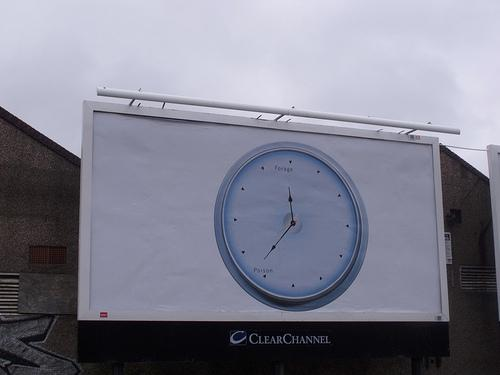How many significant objects can you identify in the image and what are some of the most important ones? There are numerous objects in the image, some important ones include the clear channel billboard, clock, graffiti, and air vent. What is unique about the clock's hands in the image? The clock's black hands are showing the time as eleven forty and are unusually large when compared to the face of the clock. List three elements featured on the billboard and provide their color. The billboard features a big clock with a silver frame, a white face, and blue border on the edge. Examine and describe the appearance of the clock on the billboard. The clock on the billboard has a silver frame, a white face, black dots marking hours, black hands, and a blue border on the edge. Mention an element of color or design that stands out in the image. A notable design element in the image is the red label and red sticker, both visually contrasting against the predominantly white and gray color scheme. Analyze and describe the placement and purpose of the Clear Channel logo in the image. The Clear Channel logo is positioned in white lettering on a black background below the billboard, indicating the ownership of the billboard. What is the state of the sky above the advertisement? The sky is gray and gloomy, indicating an overcast or stormy atmosphere. What does the graffiti under the advertisement look like, based on the image? The graffiti under the advertisement is mostly white with a black "S" painted on the wall and black letters on a white background. Provide a brief description of the overall atmosphere in the image. The image has a gloomy atmosphere with gray and overcast storm skies. What is the major object shown in the image and its purpose? A billboard featuring a clock is the main object, likely advertising a watch or clock brand. 